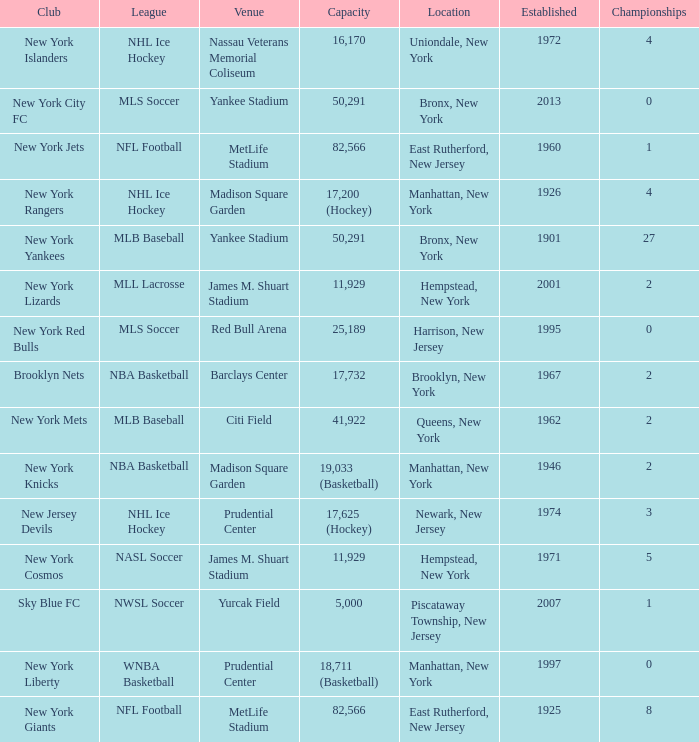When was the venue named nassau veterans memorial coliseum established?? 1972.0. 